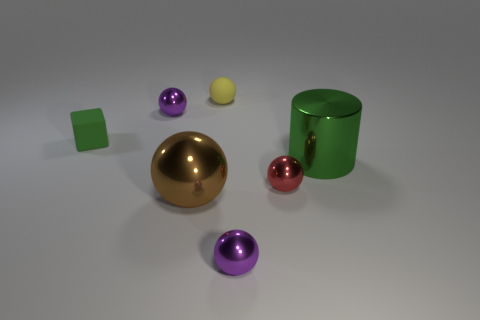Are there fewer purple objects behind the rubber sphere than small red spheres that are on the left side of the tiny red thing?
Offer a very short reply. No. What is the material of the object that is the same color as the big metallic cylinder?
Offer a very short reply. Rubber. How many objects are either purple metal objects behind the large green shiny cylinder or big red matte things?
Offer a terse response. 1. There is a green thing that is right of the cube; is it the same size as the big brown thing?
Keep it short and to the point. Yes. Are there fewer small purple spheres on the right side of the large green cylinder than big green shiny objects?
Offer a terse response. Yes. What is the material of the cylinder that is the same size as the brown object?
Your response must be concise. Metal. How many small objects are matte spheres or brown shiny spheres?
Offer a very short reply. 1. How many things are big metallic things that are in front of the tiny red object or spheres that are in front of the green cube?
Keep it short and to the point. 3. Is the number of tiny brown blocks less than the number of tiny matte spheres?
Your response must be concise. Yes. The green rubber thing that is the same size as the red thing is what shape?
Your answer should be very brief. Cube. 